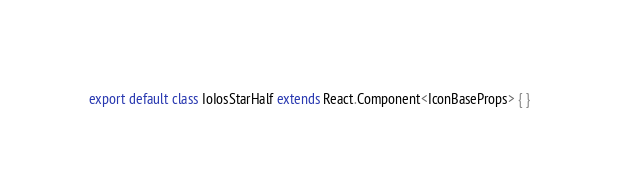Convert code to text. <code><loc_0><loc_0><loc_500><loc_500><_TypeScript_>export default class IoIosStarHalf extends React.Component<IconBaseProps> { }
</code> 